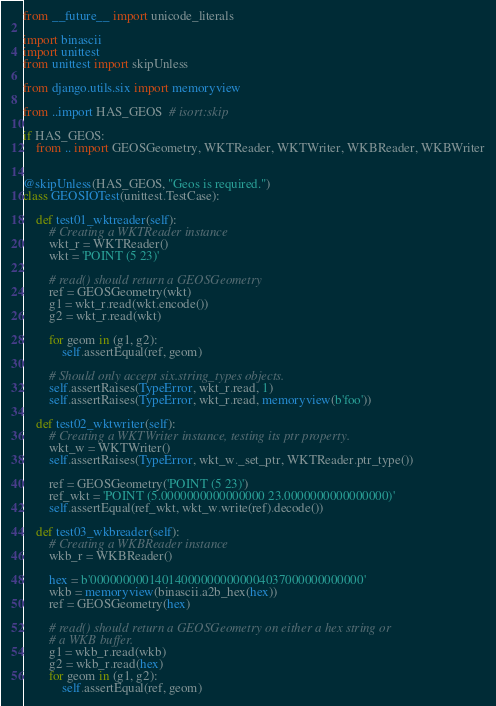<code> <loc_0><loc_0><loc_500><loc_500><_Python_>from __future__ import unicode_literals

import binascii
import unittest
from unittest import skipUnless

from django.utils.six import memoryview

from ..import HAS_GEOS  # isort:skip

if HAS_GEOS:
    from .. import GEOSGeometry, WKTReader, WKTWriter, WKBReader, WKBWriter


@skipUnless(HAS_GEOS, "Geos is required.")
class GEOSIOTest(unittest.TestCase):

    def test01_wktreader(self):
        # Creating a WKTReader instance
        wkt_r = WKTReader()
        wkt = 'POINT (5 23)'

        # read() should return a GEOSGeometry
        ref = GEOSGeometry(wkt)
        g1 = wkt_r.read(wkt.encode())
        g2 = wkt_r.read(wkt)

        for geom in (g1, g2):
            self.assertEqual(ref, geom)

        # Should only accept six.string_types objects.
        self.assertRaises(TypeError, wkt_r.read, 1)
        self.assertRaises(TypeError, wkt_r.read, memoryview(b'foo'))

    def test02_wktwriter(self):
        # Creating a WKTWriter instance, testing its ptr property.
        wkt_w = WKTWriter()
        self.assertRaises(TypeError, wkt_w._set_ptr, WKTReader.ptr_type())

        ref = GEOSGeometry('POINT (5 23)')
        ref_wkt = 'POINT (5.0000000000000000 23.0000000000000000)'
        self.assertEqual(ref_wkt, wkt_w.write(ref).decode())

    def test03_wkbreader(self):
        # Creating a WKBReader instance
        wkb_r = WKBReader()

        hex = b'000000000140140000000000004037000000000000'
        wkb = memoryview(binascii.a2b_hex(hex))
        ref = GEOSGeometry(hex)

        # read() should return a GEOSGeometry on either a hex string or
        # a WKB buffer.
        g1 = wkb_r.read(wkb)
        g2 = wkb_r.read(hex)
        for geom in (g1, g2):
            self.assertEqual(ref, geom)
</code> 